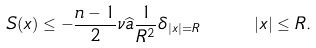Convert formula to latex. <formula><loc_0><loc_0><loc_500><loc_500>S ( x ) \leq - \frac { n - 1 } { 2 } \nu \widehat { a } \frac { 1 } { R ^ { 2 } } \delta _ { | x | = R } \quad \ | x | \leq R .</formula> 